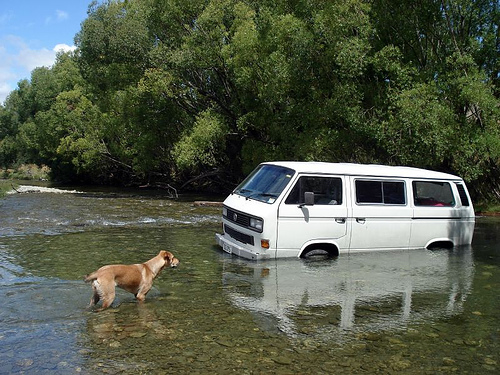<image>
Is the dog next to the van? Yes. The dog is positioned adjacent to the van, located nearby in the same general area. Is there a van in the water? Yes. The van is contained within or inside the water, showing a containment relationship. Is there a van above the water? No. The van is not positioned above the water. The vertical arrangement shows a different relationship. Where is the van in relation to the water? Is it behind the water? No. The van is not behind the water. From this viewpoint, the van appears to be positioned elsewhere in the scene. Where is the tire in relation to the water? Is it on the water? No. The tire is not positioned on the water. They may be near each other, but the tire is not supported by or resting on top of the water. Where is the water in relation to the car? Is it on the car? No. The water is not positioned on the car. They may be near each other, but the water is not supported by or resting on top of the car. Where is the dog in relation to the car? Is it in front of the car? Yes. The dog is positioned in front of the car, appearing closer to the camera viewpoint. 